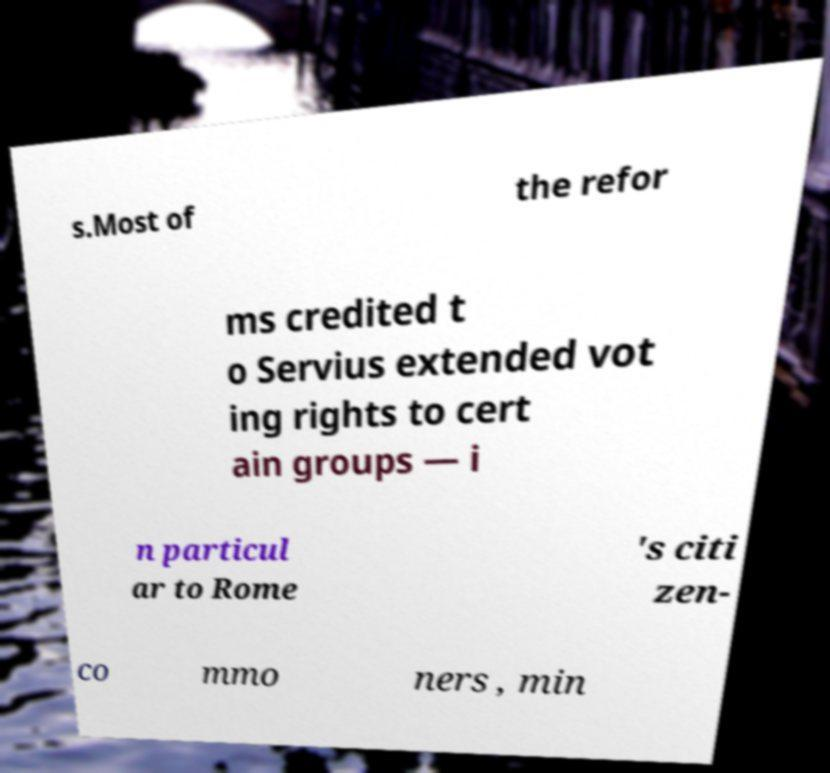Could you extract and type out the text from this image? s.Most of the refor ms credited t o Servius extended vot ing rights to cert ain groups — i n particul ar to Rome 's citi zen- co mmo ners , min 